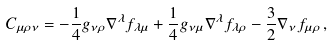Convert formula to latex. <formula><loc_0><loc_0><loc_500><loc_500>C _ { \mu \rho \nu } = - \frac { 1 } { 4 } g _ { \nu \rho } \nabla ^ { \lambda } f _ { \lambda \mu } + \frac { 1 } { 4 } g _ { \nu \mu } \nabla ^ { \lambda } f _ { \lambda \rho } - \frac { 3 } { 2 } \nabla _ { \nu } f _ { \mu \rho } \, ,</formula> 